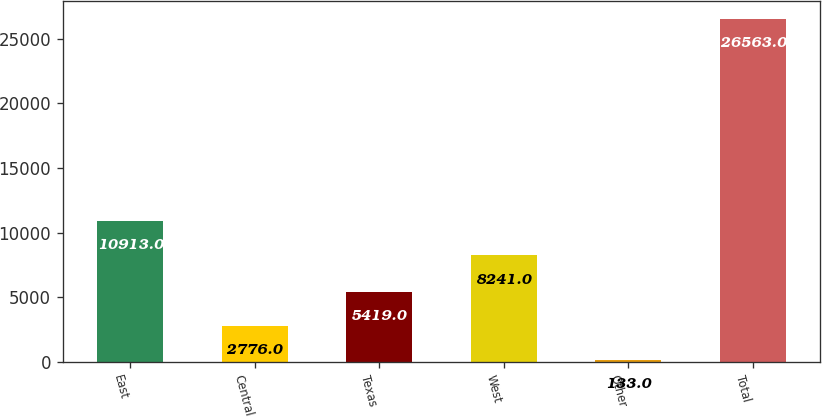Convert chart. <chart><loc_0><loc_0><loc_500><loc_500><bar_chart><fcel>East<fcel>Central<fcel>Texas<fcel>West<fcel>Other<fcel>Total<nl><fcel>10913<fcel>2776<fcel>5419<fcel>8241<fcel>133<fcel>26563<nl></chart> 